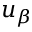Convert formula to latex. <formula><loc_0><loc_0><loc_500><loc_500>u _ { \beta }</formula> 